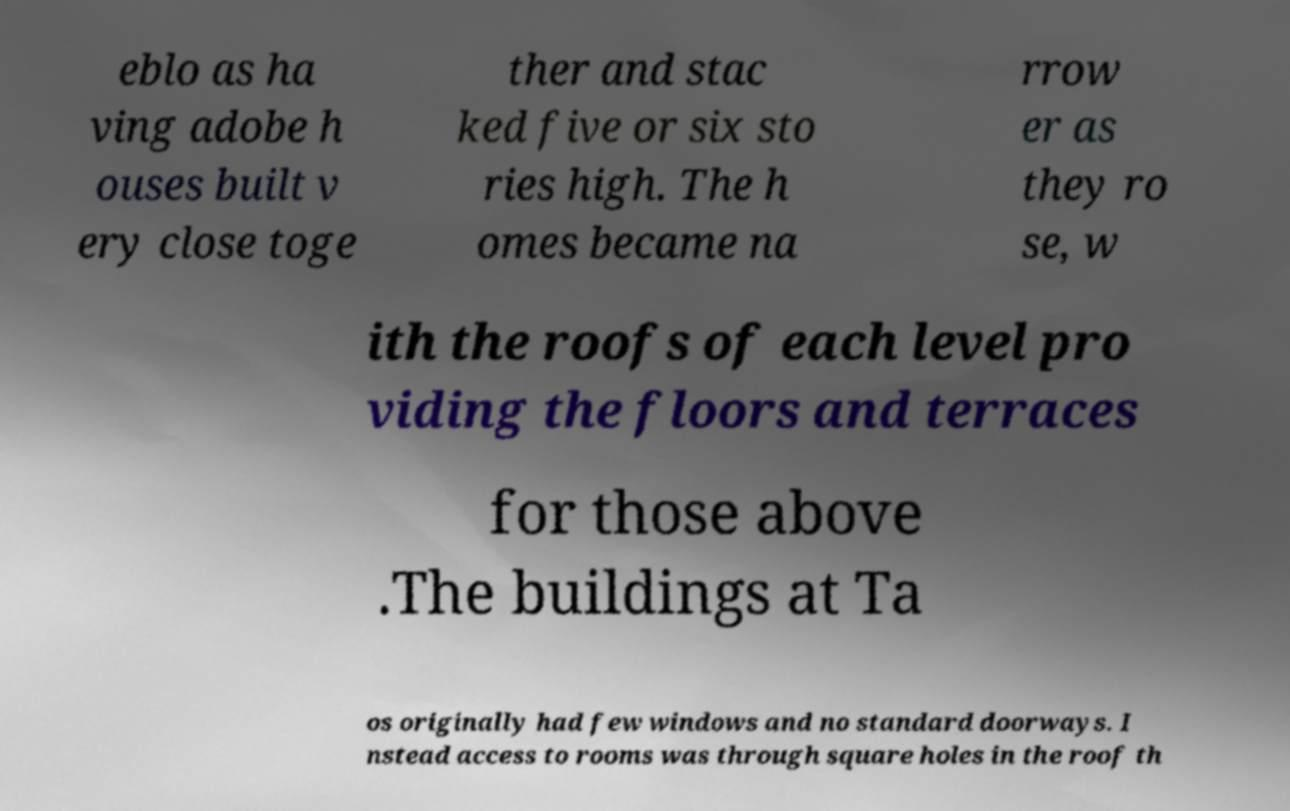Please read and relay the text visible in this image. What does it say? eblo as ha ving adobe h ouses built v ery close toge ther and stac ked five or six sto ries high. The h omes became na rrow er as they ro se, w ith the roofs of each level pro viding the floors and terraces for those above .The buildings at Ta os originally had few windows and no standard doorways. I nstead access to rooms was through square holes in the roof th 